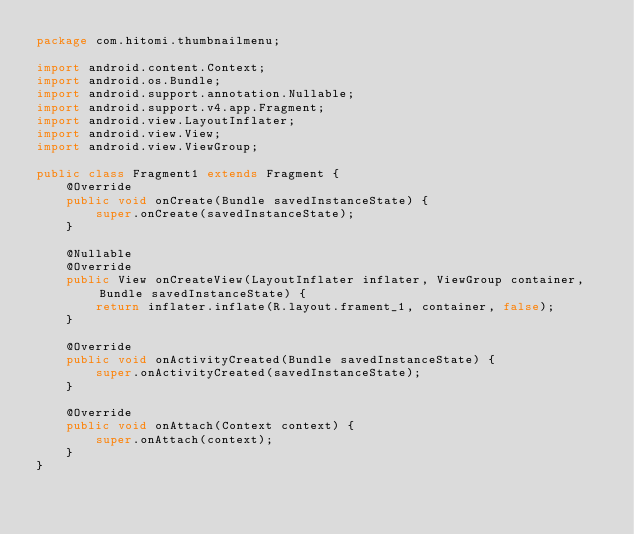Convert code to text. <code><loc_0><loc_0><loc_500><loc_500><_Java_>package com.hitomi.thumbnailmenu;

import android.content.Context;
import android.os.Bundle;
import android.support.annotation.Nullable;
import android.support.v4.app.Fragment;
import android.view.LayoutInflater;
import android.view.View;
import android.view.ViewGroup;

public class Fragment1 extends Fragment {
    @Override
    public void onCreate(Bundle savedInstanceState) {
        super.onCreate(savedInstanceState);
    }

    @Nullable
    @Override
    public View onCreateView(LayoutInflater inflater, ViewGroup container, Bundle savedInstanceState) {
        return inflater.inflate(R.layout.frament_1, container, false);
    }

    @Override
    public void onActivityCreated(Bundle savedInstanceState) {
        super.onActivityCreated(savedInstanceState);
    }

    @Override
    public void onAttach(Context context) {
        super.onAttach(context);
    }
}
</code> 